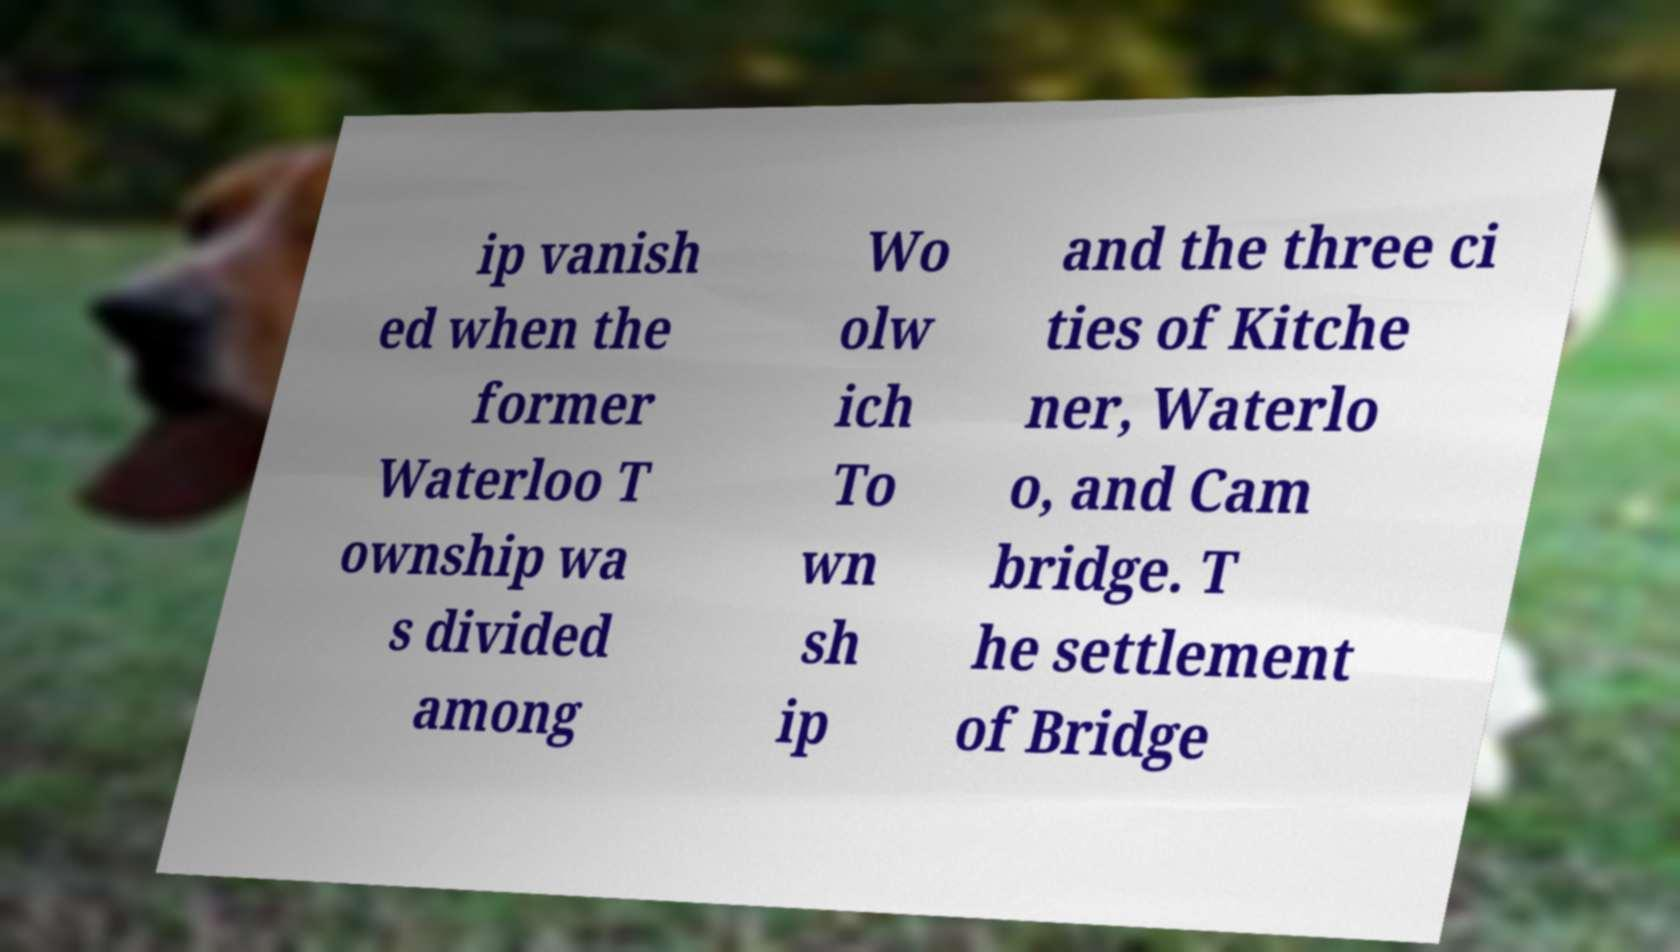Can you accurately transcribe the text from the provided image for me? ip vanish ed when the former Waterloo T ownship wa s divided among Wo olw ich To wn sh ip and the three ci ties of Kitche ner, Waterlo o, and Cam bridge. T he settlement of Bridge 